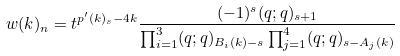<formula> <loc_0><loc_0><loc_500><loc_500>w ( k ) _ { n } = t ^ { p ^ { \prime } ( k ) _ { s } - 4 k } \frac { ( - 1 ) ^ { s } ( q ; q ) _ { s + 1 } } { \prod _ { i = 1 } ^ { 3 } ( q ; q ) _ { B _ { i } ( k ) - s } \prod _ { j = 1 } ^ { 4 } ( q ; q ) _ { s - A _ { j } ( k ) } }</formula> 